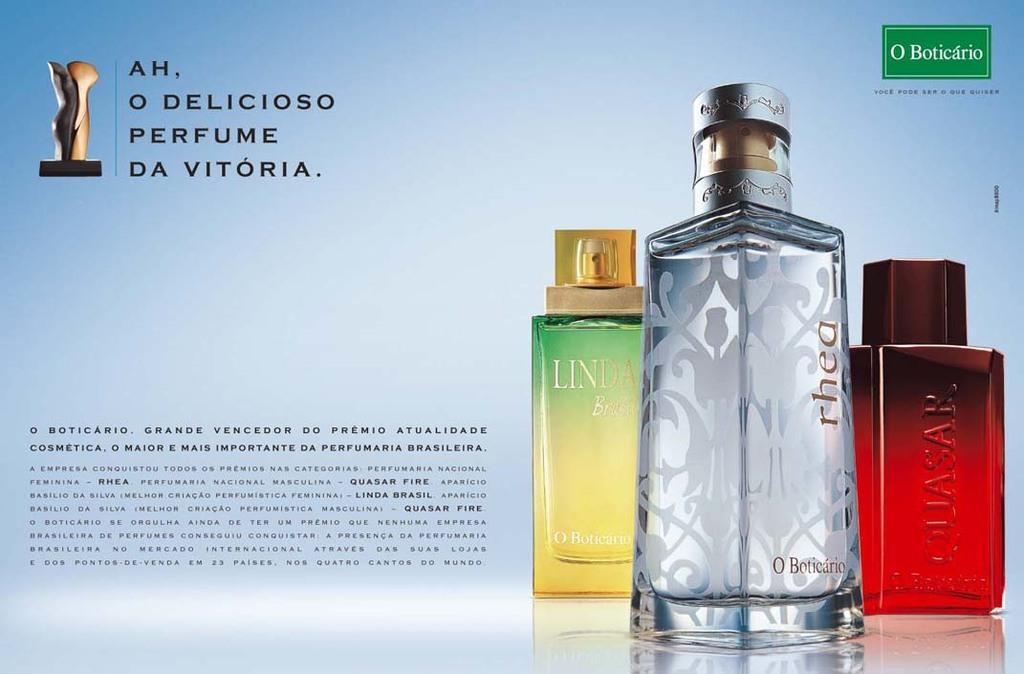<image>
Present a compact description of the photo's key features. Da Vitoria perfume ad, showcasing 3 different scents for you to purchase. 